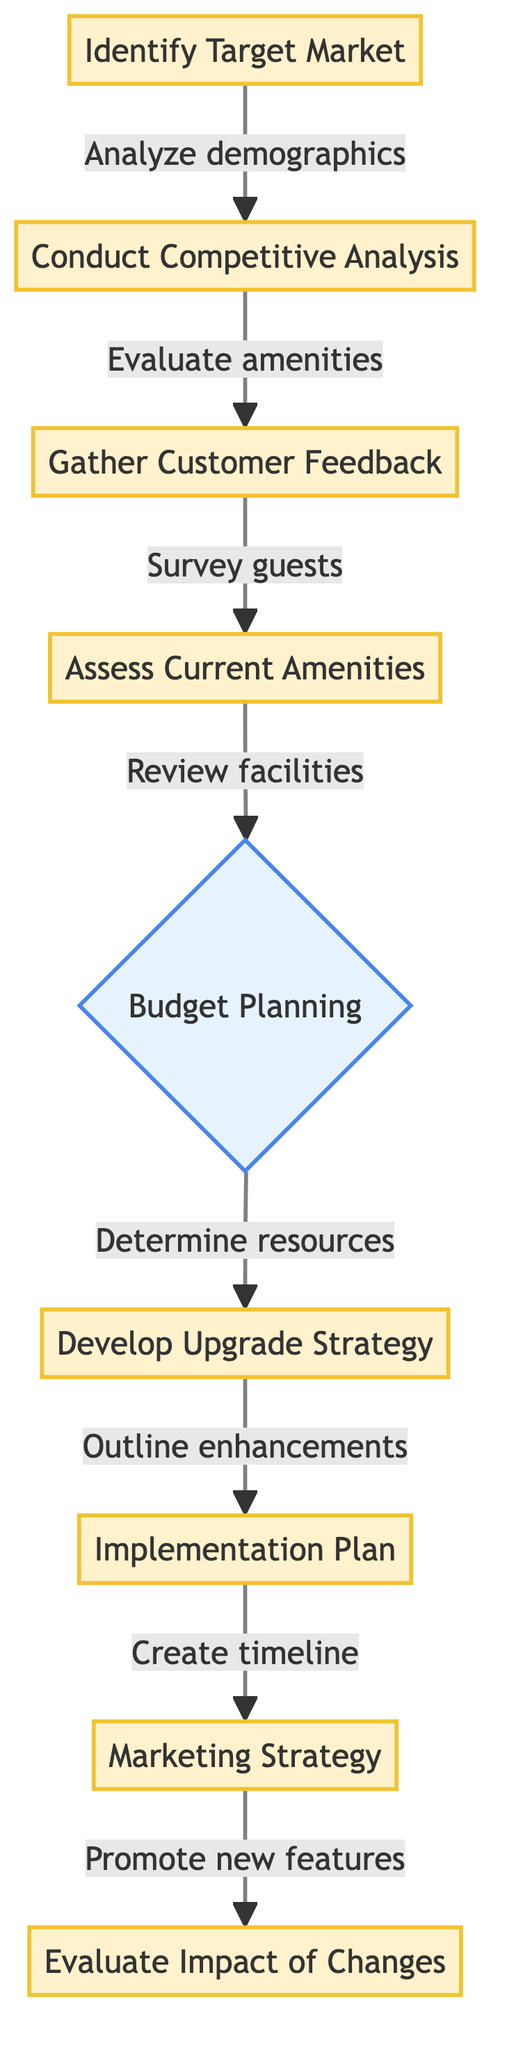What is the first step in the decision-making process? The first step shown in the flowchart is "Identify Target Market." This is indicated as the starting point of the diagram, leading to subsequent steps.
Answer: Identify Target Market How many nodes are in the flowchart? The flowchart has a total of nine nodes, which are all the distinct steps or processes outlined from start to finish.
Answer: Nine What comes after "Assess Current Amenities"? "Budget Planning" follows "Assess Current Amenities" as the next step in the flowchart, indicating that after reviewing existing facilities, the available budget must be considered.
Answer: Budget Planning Which step involves surveying guests? The step that involves surveying guests is "Gather Customer Feedback." It directly follows the competitive analysis and serves to collect insights from current and potential customers.
Answer: Gather Customer Feedback What is the last step in the process? The last step in the decision-making process is "Evaluate Impact of Changes," which signifies monitoring the results of the upgrades implemented earlier in the flowchart.
Answer: Evaluate Impact of Changes What determines the next action after assessing current amenities? The next action after assessing current amenities is determined by "Budget Planning." This indicates a financial assessment is required before proceeding with any upgrade strategies.
Answer: Budget Planning How do you move from "Develop Upgrade Strategy" to the subsequent step? Moving from "Develop Upgrade Strategy" to the next step involves the action indicated, which is creating an "Implementation Plan." This demonstrates the need for a structured plan following upgrade strategies.
Answer: Implementation Plan What type of strategy is developed after the implementation plan? After the implementation plan, a "Marketing Strategy" is developed to promote the new amenities effectively and attract potential guests.
Answer: Marketing Strategy Which phase includes monitoring guest satisfaction? The phase that includes monitoring guest satisfaction is "Evaluate Impact of Changes." This final step assesses the effectiveness of the implemented upgrades based on guest feedback and occupancy rates.
Answer: Evaluate Impact of Changes 